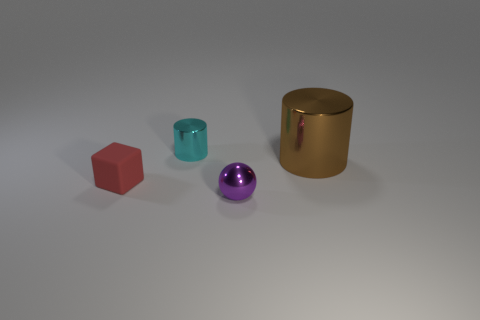There is a metal thing in front of the cylinder in front of the tiny cylinder; is there a tiny purple ball behind it? Indeed, behind the metallic cylinder, there is a tiny purple ball, partially concealed yet still visible. 